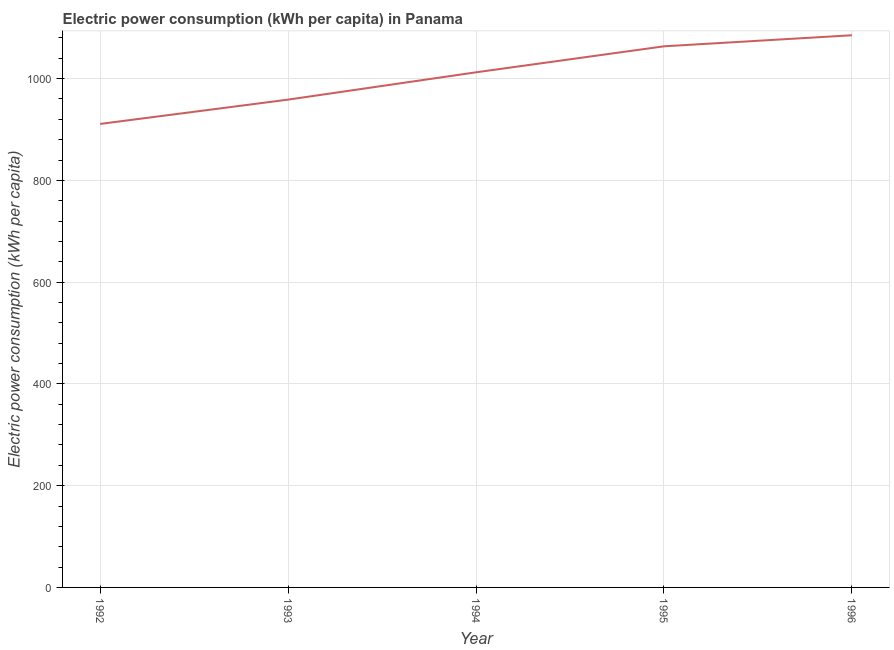What is the electric power consumption in 1993?
Your response must be concise. 958.72. Across all years, what is the maximum electric power consumption?
Your answer should be compact. 1085.21. Across all years, what is the minimum electric power consumption?
Your answer should be compact. 910.95. In which year was the electric power consumption maximum?
Your answer should be compact. 1996. What is the sum of the electric power consumption?
Ensure brevity in your answer.  5030.79. What is the difference between the electric power consumption in 1992 and 1995?
Your answer should be compact. -152.55. What is the average electric power consumption per year?
Provide a succinct answer. 1006.16. What is the median electric power consumption?
Offer a very short reply. 1012.41. What is the ratio of the electric power consumption in 1994 to that in 1995?
Your response must be concise. 0.95. Is the difference between the electric power consumption in 1993 and 1996 greater than the difference between any two years?
Provide a short and direct response. No. What is the difference between the highest and the second highest electric power consumption?
Give a very brief answer. 21.71. What is the difference between the highest and the lowest electric power consumption?
Provide a short and direct response. 174.26. Does the electric power consumption monotonically increase over the years?
Offer a terse response. Yes. What is the difference between two consecutive major ticks on the Y-axis?
Your answer should be compact. 200. Are the values on the major ticks of Y-axis written in scientific E-notation?
Make the answer very short. No. Does the graph contain grids?
Make the answer very short. Yes. What is the title of the graph?
Your answer should be very brief. Electric power consumption (kWh per capita) in Panama. What is the label or title of the Y-axis?
Ensure brevity in your answer.  Electric power consumption (kWh per capita). What is the Electric power consumption (kWh per capita) in 1992?
Ensure brevity in your answer.  910.95. What is the Electric power consumption (kWh per capita) in 1993?
Offer a very short reply. 958.72. What is the Electric power consumption (kWh per capita) in 1994?
Make the answer very short. 1012.41. What is the Electric power consumption (kWh per capita) of 1995?
Provide a short and direct response. 1063.5. What is the Electric power consumption (kWh per capita) of 1996?
Your response must be concise. 1085.21. What is the difference between the Electric power consumption (kWh per capita) in 1992 and 1993?
Your answer should be compact. -47.77. What is the difference between the Electric power consumption (kWh per capita) in 1992 and 1994?
Your answer should be compact. -101.45. What is the difference between the Electric power consumption (kWh per capita) in 1992 and 1995?
Ensure brevity in your answer.  -152.55. What is the difference between the Electric power consumption (kWh per capita) in 1992 and 1996?
Offer a terse response. -174.26. What is the difference between the Electric power consumption (kWh per capita) in 1993 and 1994?
Your answer should be very brief. -53.69. What is the difference between the Electric power consumption (kWh per capita) in 1993 and 1995?
Your answer should be very brief. -104.78. What is the difference between the Electric power consumption (kWh per capita) in 1993 and 1996?
Provide a short and direct response. -126.49. What is the difference between the Electric power consumption (kWh per capita) in 1994 and 1995?
Provide a succinct answer. -51.1. What is the difference between the Electric power consumption (kWh per capita) in 1994 and 1996?
Ensure brevity in your answer.  -72.81. What is the difference between the Electric power consumption (kWh per capita) in 1995 and 1996?
Provide a short and direct response. -21.71. What is the ratio of the Electric power consumption (kWh per capita) in 1992 to that in 1993?
Your answer should be very brief. 0.95. What is the ratio of the Electric power consumption (kWh per capita) in 1992 to that in 1995?
Provide a succinct answer. 0.86. What is the ratio of the Electric power consumption (kWh per capita) in 1992 to that in 1996?
Offer a very short reply. 0.84. What is the ratio of the Electric power consumption (kWh per capita) in 1993 to that in 1994?
Offer a terse response. 0.95. What is the ratio of the Electric power consumption (kWh per capita) in 1993 to that in 1995?
Your answer should be compact. 0.9. What is the ratio of the Electric power consumption (kWh per capita) in 1993 to that in 1996?
Your answer should be very brief. 0.88. What is the ratio of the Electric power consumption (kWh per capita) in 1994 to that in 1995?
Your answer should be compact. 0.95. What is the ratio of the Electric power consumption (kWh per capita) in 1994 to that in 1996?
Provide a short and direct response. 0.93. 